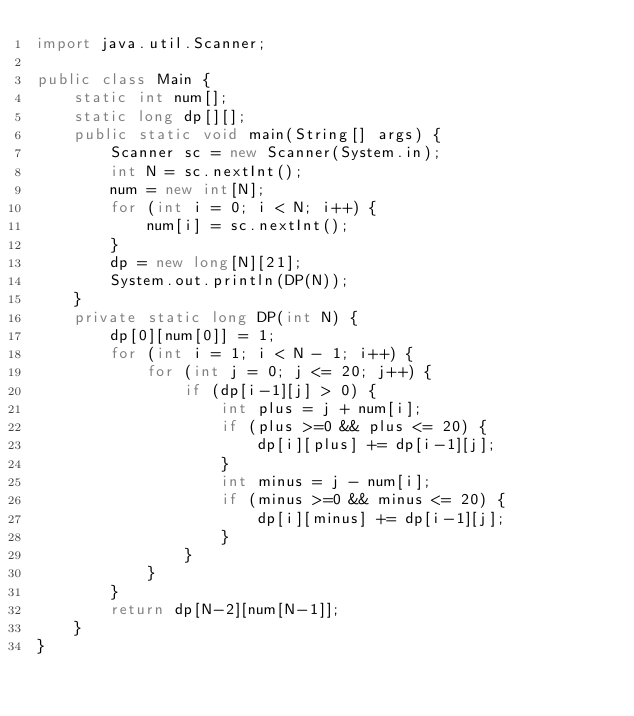<code> <loc_0><loc_0><loc_500><loc_500><_Java_>import java.util.Scanner;

public class Main {
	static int num[];
	static long dp[][];
	public static void main(String[] args) {
		Scanner sc = new Scanner(System.in);
		int N = sc.nextInt();
		num = new int[N];
		for (int i = 0; i < N; i++) {
			num[i] = sc.nextInt();
		}
		dp = new long[N][21];
		System.out.println(DP(N));
	}
	private static long DP(int N) {
		dp[0][num[0]] = 1;
		for (int i = 1; i < N - 1; i++) {
			for (int j = 0; j <= 20; j++) {
				if (dp[i-1][j] > 0) {
					int plus = j + num[i];
					if (plus >=0 && plus <= 20) {
						dp[i][plus] += dp[i-1][j];
					}
					int minus = j - num[i];
					if (minus >=0 && minus <= 20) {
						dp[i][minus] += dp[i-1][j];
					}
				}
			}
		}
		return dp[N-2][num[N-1]];
	}
}</code> 